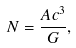Convert formula to latex. <formula><loc_0><loc_0><loc_500><loc_500>N = \frac { A c ^ { 3 } } { G } ,</formula> 